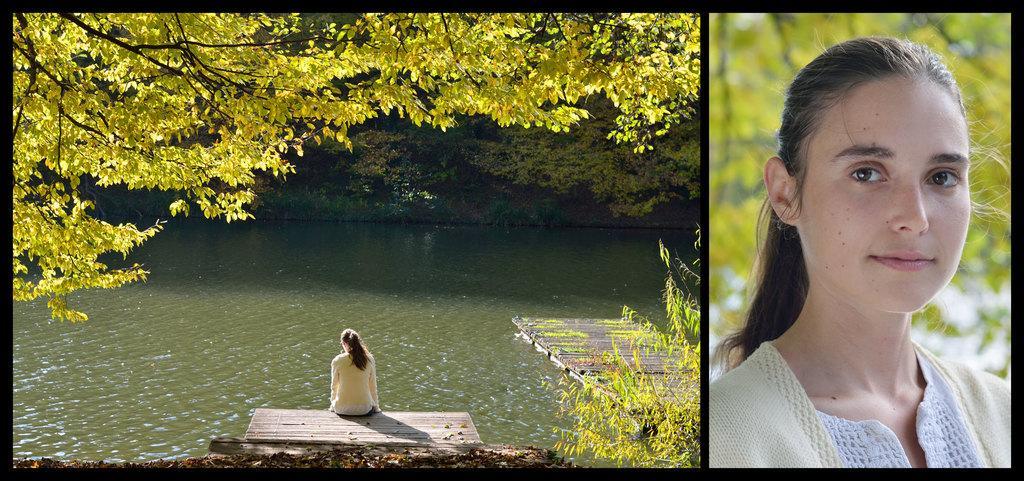Can you describe this image briefly? On the right side of the image we can see a man´s face. On the left side of the image we can see a girl sitting at the water. In the background we can see trees. 